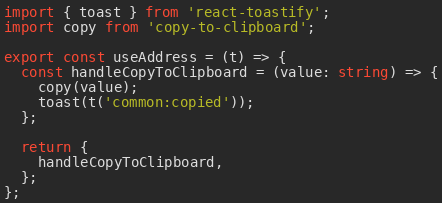Convert code to text. <code><loc_0><loc_0><loc_500><loc_500><_TypeScript_>import { toast } from 'react-toastify';
import copy from 'copy-to-clipboard';

export const useAddress = (t) => {
  const handleCopyToClipboard = (value: string) => {
    copy(value);
    toast(t('common:copied'));
  };

  return {
    handleCopyToClipboard,
  };
};
</code> 